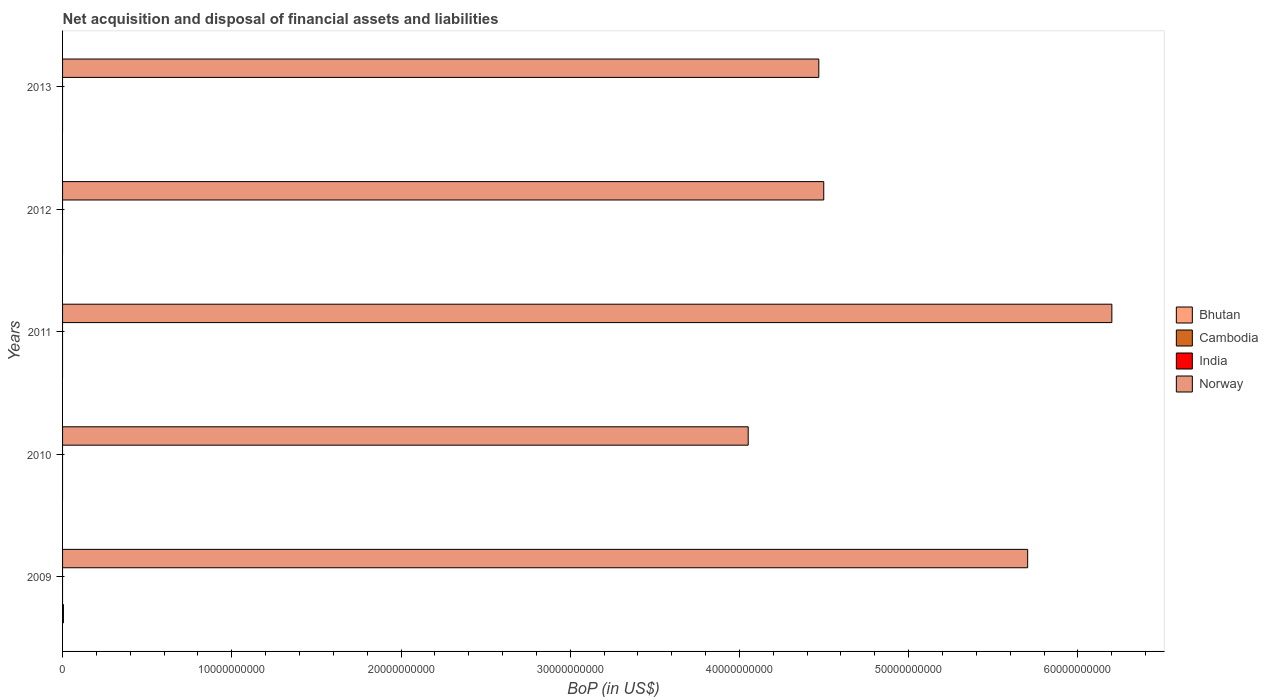How many different coloured bars are there?
Make the answer very short. 2. Are the number of bars per tick equal to the number of legend labels?
Offer a terse response. No. What is the label of the 3rd group of bars from the top?
Offer a terse response. 2011. What is the Balance of Payments in Norway in 2013?
Make the answer very short. 4.47e+1. Across all years, what is the maximum Balance of Payments in Norway?
Keep it short and to the point. 6.20e+1. In which year was the Balance of Payments in Bhutan maximum?
Your answer should be compact. 2009. What is the total Balance of Payments in Bhutan in the graph?
Your answer should be very brief. 5.18e+07. What is the difference between the Balance of Payments in Norway in 2010 and that in 2011?
Your response must be concise. -2.15e+1. What is the difference between the Balance of Payments in Cambodia in 2010 and the Balance of Payments in Norway in 2009?
Offer a terse response. -5.70e+1. What is the average Balance of Payments in Bhutan per year?
Your answer should be very brief. 1.04e+07. In how many years, is the Balance of Payments in Norway greater than 30000000000 US$?
Ensure brevity in your answer.  5. What is the ratio of the Balance of Payments in Norway in 2010 to that in 2012?
Provide a succinct answer. 0.9. What is the difference between the highest and the second highest Balance of Payments in Norway?
Provide a succinct answer. 4.97e+09. What is the difference between the highest and the lowest Balance of Payments in Norway?
Offer a very short reply. 2.15e+1. How many bars are there?
Make the answer very short. 6. How many years are there in the graph?
Keep it short and to the point. 5. What is the difference between two consecutive major ticks on the X-axis?
Ensure brevity in your answer.  1.00e+1. Are the values on the major ticks of X-axis written in scientific E-notation?
Provide a succinct answer. No. How many legend labels are there?
Make the answer very short. 4. How are the legend labels stacked?
Your response must be concise. Vertical. What is the title of the graph?
Make the answer very short. Net acquisition and disposal of financial assets and liabilities. Does "Yemen, Rep." appear as one of the legend labels in the graph?
Offer a very short reply. No. What is the label or title of the X-axis?
Give a very brief answer. BoP (in US$). What is the label or title of the Y-axis?
Give a very brief answer. Years. What is the BoP (in US$) of Bhutan in 2009?
Ensure brevity in your answer.  5.18e+07. What is the BoP (in US$) in Cambodia in 2009?
Your answer should be very brief. 0. What is the BoP (in US$) in India in 2009?
Offer a terse response. 0. What is the BoP (in US$) of Norway in 2009?
Offer a very short reply. 5.70e+1. What is the BoP (in US$) in India in 2010?
Offer a very short reply. 0. What is the BoP (in US$) in Norway in 2010?
Your answer should be very brief. 4.05e+1. What is the BoP (in US$) of Bhutan in 2011?
Give a very brief answer. 0. What is the BoP (in US$) in Cambodia in 2011?
Your response must be concise. 0. What is the BoP (in US$) of India in 2011?
Ensure brevity in your answer.  0. What is the BoP (in US$) in Norway in 2011?
Offer a terse response. 6.20e+1. What is the BoP (in US$) of India in 2012?
Your response must be concise. 0. What is the BoP (in US$) of Norway in 2012?
Your answer should be compact. 4.50e+1. What is the BoP (in US$) in Bhutan in 2013?
Make the answer very short. 0. What is the BoP (in US$) of Norway in 2013?
Keep it short and to the point. 4.47e+1. Across all years, what is the maximum BoP (in US$) of Bhutan?
Make the answer very short. 5.18e+07. Across all years, what is the maximum BoP (in US$) in Norway?
Your answer should be very brief. 6.20e+1. Across all years, what is the minimum BoP (in US$) in Norway?
Provide a succinct answer. 4.05e+1. What is the total BoP (in US$) in Bhutan in the graph?
Give a very brief answer. 5.18e+07. What is the total BoP (in US$) of Cambodia in the graph?
Give a very brief answer. 0. What is the total BoP (in US$) in Norway in the graph?
Provide a short and direct response. 2.49e+11. What is the difference between the BoP (in US$) of Norway in 2009 and that in 2010?
Offer a terse response. 1.65e+1. What is the difference between the BoP (in US$) in Norway in 2009 and that in 2011?
Make the answer very short. -4.97e+09. What is the difference between the BoP (in US$) of Norway in 2009 and that in 2012?
Offer a very short reply. 1.21e+1. What is the difference between the BoP (in US$) in Norway in 2009 and that in 2013?
Provide a short and direct response. 1.23e+1. What is the difference between the BoP (in US$) of Norway in 2010 and that in 2011?
Ensure brevity in your answer.  -2.15e+1. What is the difference between the BoP (in US$) of Norway in 2010 and that in 2012?
Your answer should be very brief. -4.46e+09. What is the difference between the BoP (in US$) in Norway in 2010 and that in 2013?
Provide a short and direct response. -4.17e+09. What is the difference between the BoP (in US$) in Norway in 2011 and that in 2012?
Make the answer very short. 1.70e+1. What is the difference between the BoP (in US$) in Norway in 2011 and that in 2013?
Keep it short and to the point. 1.73e+1. What is the difference between the BoP (in US$) of Norway in 2012 and that in 2013?
Give a very brief answer. 2.92e+08. What is the difference between the BoP (in US$) of Bhutan in 2009 and the BoP (in US$) of Norway in 2010?
Make the answer very short. -4.05e+1. What is the difference between the BoP (in US$) of Bhutan in 2009 and the BoP (in US$) of Norway in 2011?
Make the answer very short. -6.20e+1. What is the difference between the BoP (in US$) in Bhutan in 2009 and the BoP (in US$) in Norway in 2012?
Make the answer very short. -4.49e+1. What is the difference between the BoP (in US$) in Bhutan in 2009 and the BoP (in US$) in Norway in 2013?
Offer a very short reply. -4.46e+1. What is the average BoP (in US$) of Bhutan per year?
Give a very brief answer. 1.04e+07. What is the average BoP (in US$) in Norway per year?
Offer a terse response. 4.98e+1. In the year 2009, what is the difference between the BoP (in US$) in Bhutan and BoP (in US$) in Norway?
Your response must be concise. -5.70e+1. What is the ratio of the BoP (in US$) of Norway in 2009 to that in 2010?
Your answer should be very brief. 1.41. What is the ratio of the BoP (in US$) in Norway in 2009 to that in 2011?
Your response must be concise. 0.92. What is the ratio of the BoP (in US$) of Norway in 2009 to that in 2012?
Ensure brevity in your answer.  1.27. What is the ratio of the BoP (in US$) of Norway in 2009 to that in 2013?
Give a very brief answer. 1.28. What is the ratio of the BoP (in US$) of Norway in 2010 to that in 2011?
Your answer should be compact. 0.65. What is the ratio of the BoP (in US$) in Norway in 2010 to that in 2012?
Your answer should be very brief. 0.9. What is the ratio of the BoP (in US$) in Norway in 2010 to that in 2013?
Make the answer very short. 0.91. What is the ratio of the BoP (in US$) of Norway in 2011 to that in 2012?
Your response must be concise. 1.38. What is the ratio of the BoP (in US$) of Norway in 2011 to that in 2013?
Ensure brevity in your answer.  1.39. What is the difference between the highest and the second highest BoP (in US$) in Norway?
Ensure brevity in your answer.  4.97e+09. What is the difference between the highest and the lowest BoP (in US$) in Bhutan?
Offer a terse response. 5.18e+07. What is the difference between the highest and the lowest BoP (in US$) of Norway?
Your response must be concise. 2.15e+1. 